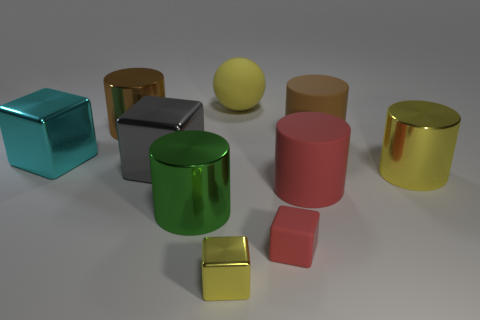Subtract all metallic cubes. How many cubes are left? 1 Subtract all yellow cylinders. How many cylinders are left? 4 Subtract 1 yellow cubes. How many objects are left? 9 Subtract all balls. How many objects are left? 9 Subtract 4 cylinders. How many cylinders are left? 1 Subtract all blue blocks. Subtract all blue cylinders. How many blocks are left? 4 Subtract all gray spheres. How many yellow cylinders are left? 1 Subtract all tiny purple matte balls. Subtract all brown metallic objects. How many objects are left? 9 Add 4 cyan cubes. How many cyan cubes are left? 5 Add 2 tiny green metallic things. How many tiny green metallic things exist? 2 